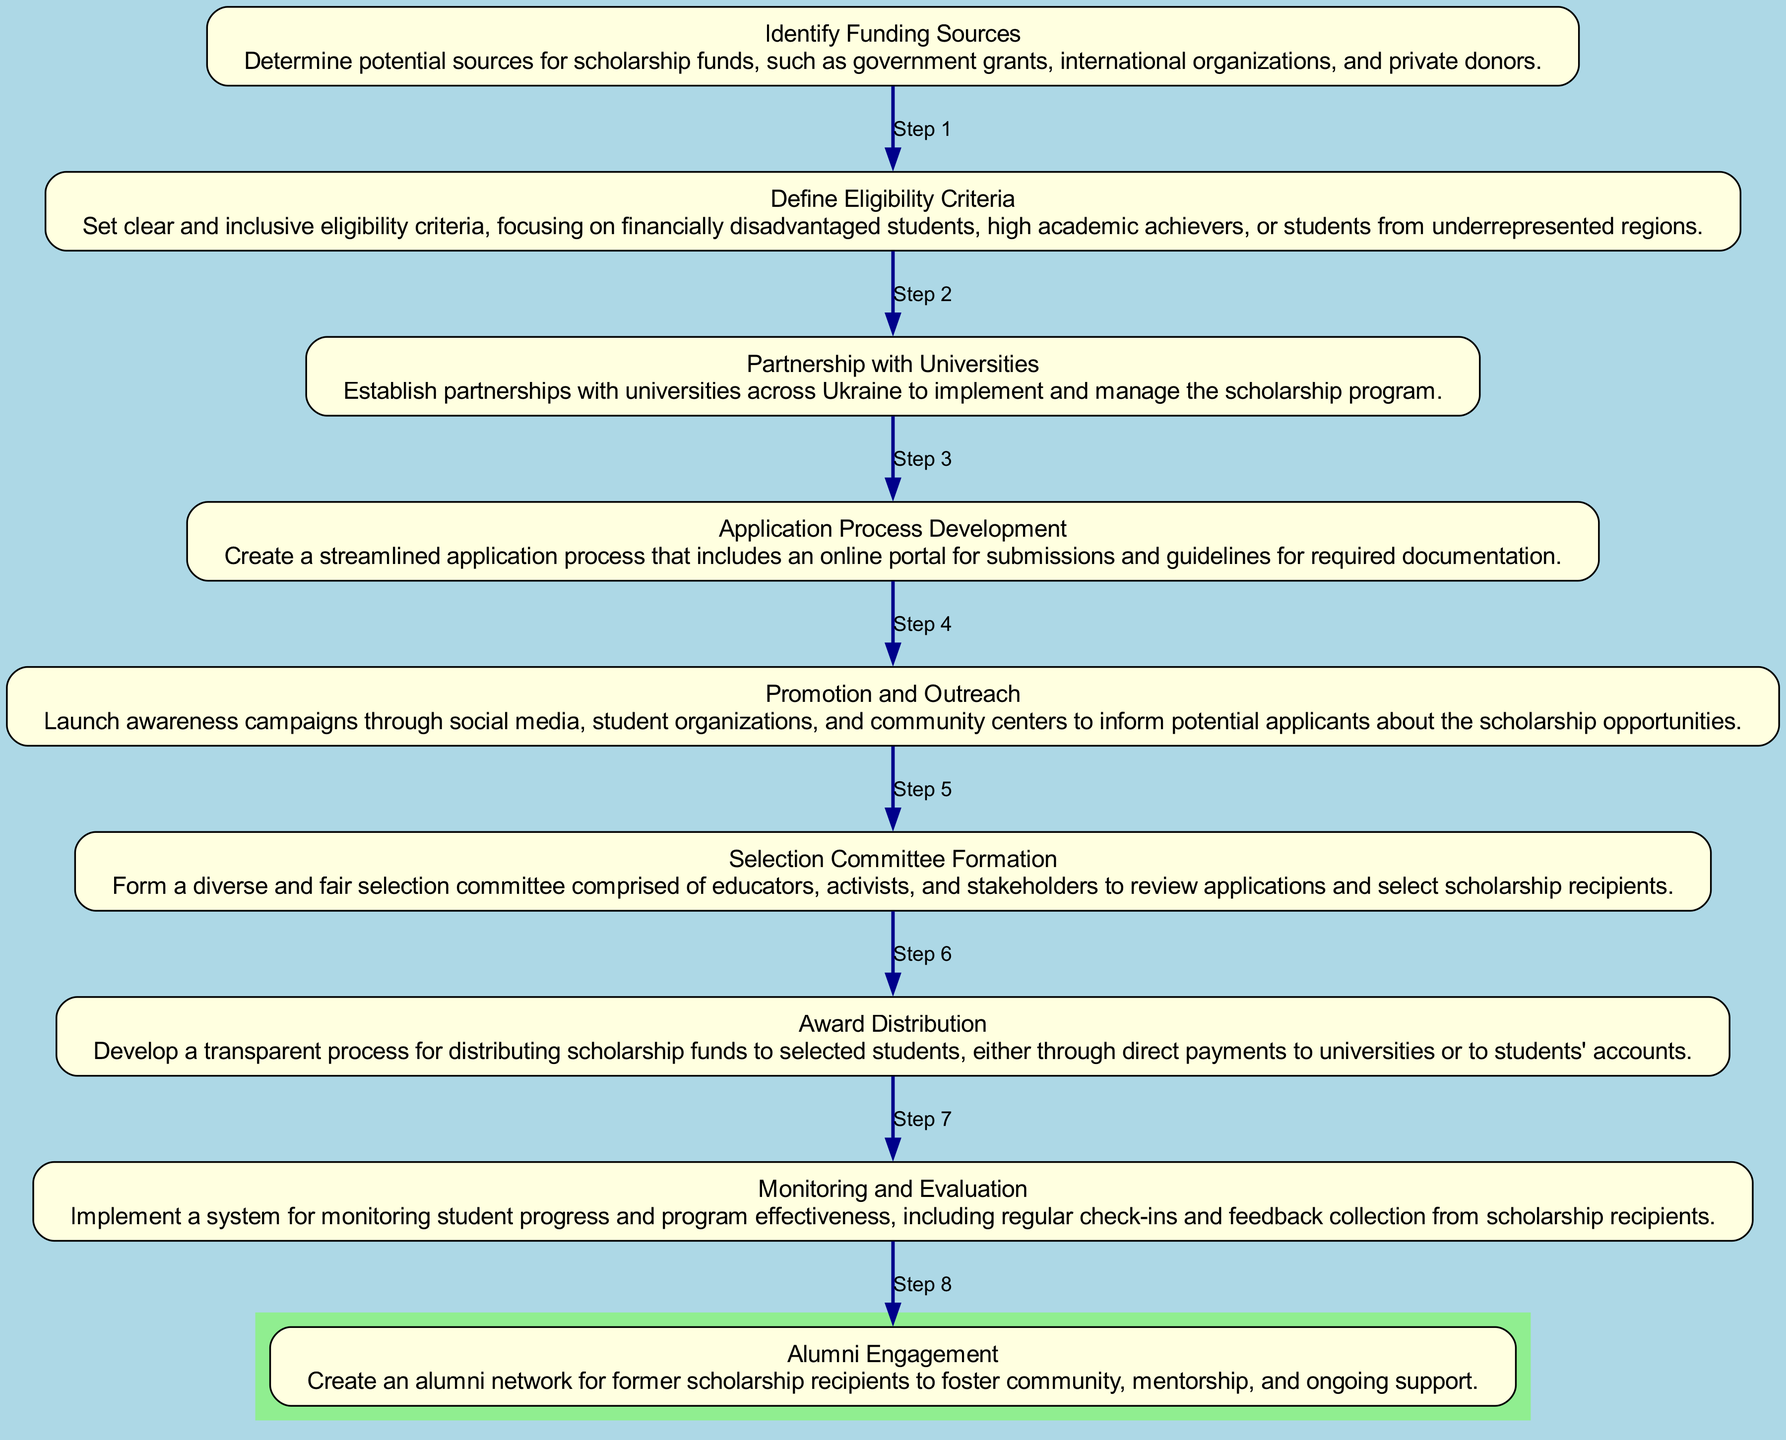What is the first step in the scholarship program implementation? The diagram shows that the first step is "Identify Funding Sources," which is the initial action before any other processes can take place.
Answer: Identify Funding Sources How many total steps are there in the flow chart? By counting each node in the diagram, we find there are nine distinct steps listed, which represent the entire process from start to finish.
Answer: Nine Which step involves creating an application portal? The step that addresses the application process is "Application Process Development," highlighting the creation of an online portal for submissions.
Answer: Application Process Development What is the last step in the implementation process? The final step mentioned in the flow chart is "Alumni Engagement," indicating the importance of maintaining connections with scholarship recipients after they complete their studies.
Answer: Alumni Engagement Which step follows "Define Eligibility Criteria"? "Partnership with Universities" is the step that directly follows "Define Eligibility Criteria" in the sequential process outlined in the diagram.
Answer: Partnership with Universities What role does the "Selection Committee Formation" play? The committee is formed to ensure a fair and diverse review process of scholarship applications, selecting recipients based on established criteria.
Answer: Review applications Which two steps focus on communication? The steps "Promotion and Outreach" and "Monitoring and Evaluation" both emphasize establishing communication channels, one for raising awareness about scholarships and the other for ongoing feedback from recipients.
Answer: Promotion and Outreach; Monitoring and Evaluation What indicates the completion of the scholarship distribution process? The step "Award Distribution" signifies the completion of the initial funding allocation to scholarship recipients, marking the end of the funding distribution phase.
Answer: Award Distribution What step involves assessing the effectiveness of the program? "Monitoring and Evaluation" is the designated step where the program's effectiveness is appraised based on student progress and feedback.
Answer: Monitoring and Evaluation 